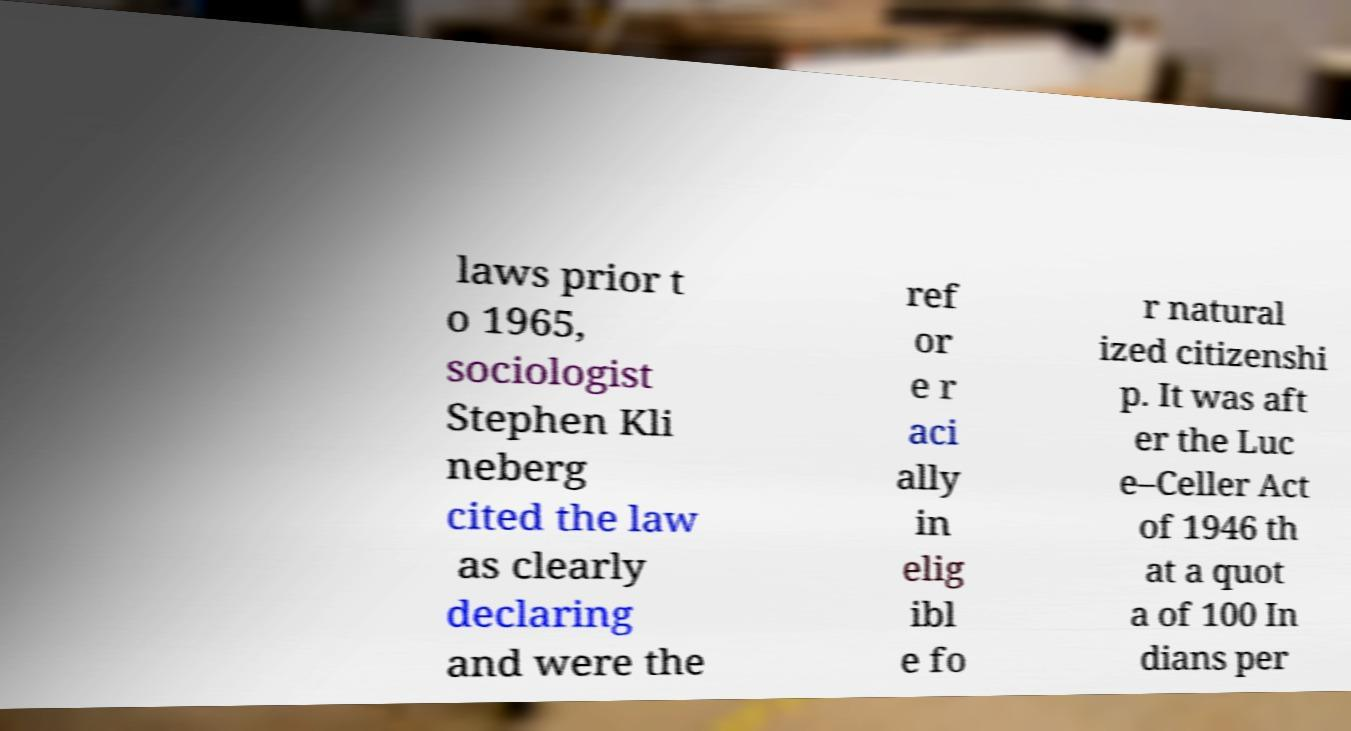Can you accurately transcribe the text from the provided image for me? laws prior t o 1965, sociologist Stephen Kli neberg cited the law as clearly declaring and were the ref or e r aci ally in elig ibl e fo r natural ized citizenshi p. It was aft er the Luc e–Celler Act of 1946 th at a quot a of 100 In dians per 